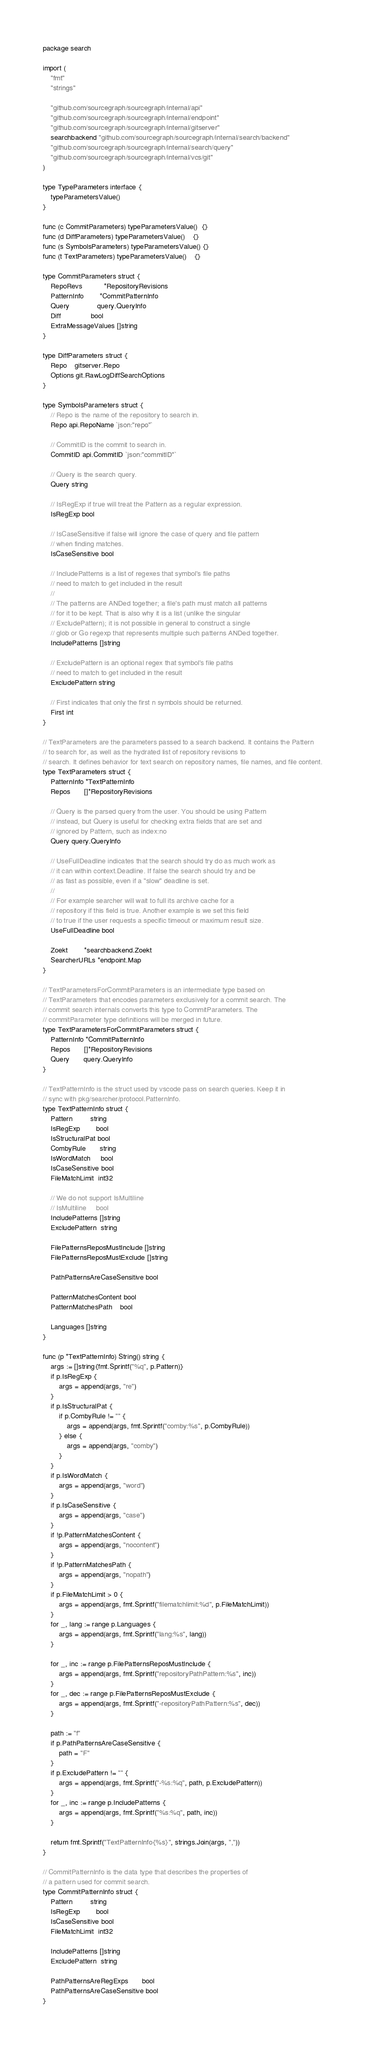Convert code to text. <code><loc_0><loc_0><loc_500><loc_500><_Go_>package search

import (
	"fmt"
	"strings"

	"github.com/sourcegraph/sourcegraph/internal/api"
	"github.com/sourcegraph/sourcegraph/internal/endpoint"
	"github.com/sourcegraph/sourcegraph/internal/gitserver"
	searchbackend "github.com/sourcegraph/sourcegraph/internal/search/backend"
	"github.com/sourcegraph/sourcegraph/internal/search/query"
	"github.com/sourcegraph/sourcegraph/internal/vcs/git"
)

type TypeParameters interface {
	typeParametersValue()
}

func (c CommitParameters) typeParametersValue()  {}
func (d DiffParameters) typeParametersValue()    {}
func (s SymbolsParameters) typeParametersValue() {}
func (t TextParameters) typeParametersValue()    {}

type CommitParameters struct {
	RepoRevs           *RepositoryRevisions
	PatternInfo        *CommitPatternInfo
	Query              query.QueryInfo
	Diff               bool
	ExtraMessageValues []string
}

type DiffParameters struct {
	Repo    gitserver.Repo
	Options git.RawLogDiffSearchOptions
}

type SymbolsParameters struct {
	// Repo is the name of the repository to search in.
	Repo api.RepoName `json:"repo"`

	// CommitID is the commit to search in.
	CommitID api.CommitID `json:"commitID"`

	// Query is the search query.
	Query string

	// IsRegExp if true will treat the Pattern as a regular expression.
	IsRegExp bool

	// IsCaseSensitive if false will ignore the case of query and file pattern
	// when finding matches.
	IsCaseSensitive bool

	// IncludePatterns is a list of regexes that symbol's file paths
	// need to match to get included in the result
	//
	// The patterns are ANDed together; a file's path must match all patterns
	// for it to be kept. That is also why it is a list (unlike the singular
	// ExcludePattern); it is not possible in general to construct a single
	// glob or Go regexp that represents multiple such patterns ANDed together.
	IncludePatterns []string

	// ExcludePattern is an optional regex that symbol's file paths
	// need to match to get included in the result
	ExcludePattern string

	// First indicates that only the first n symbols should be returned.
	First int
}

// TextParameters are the parameters passed to a search backend. It contains the Pattern
// to search for, as well as the hydrated list of repository revisions to
// search. It defines behavior for text search on repository names, file names, and file content.
type TextParameters struct {
	PatternInfo *TextPatternInfo
	Repos       []*RepositoryRevisions

	// Query is the parsed query from the user. You should be using Pattern
	// instead, but Query is useful for checking extra fields that are set and
	// ignored by Pattern, such as index:no
	Query query.QueryInfo

	// UseFullDeadline indicates that the search should try do as much work as
	// it can within context.Deadline. If false the search should try and be
	// as fast as possible, even if a "slow" deadline is set.
	//
	// For example searcher will wait to full its archive cache for a
	// repository if this field is true. Another example is we set this field
	// to true if the user requests a specific timeout or maximum result size.
	UseFullDeadline bool

	Zoekt        *searchbackend.Zoekt
	SearcherURLs *endpoint.Map
}

// TextParametersForCommitParameters is an intermediate type based on
// TextParameters that encodes parameters exclusively for a commit search. The
// commit search internals converts this type to CommitParameters. The
// commitParameter type definitions will be merged in future.
type TextParametersForCommitParameters struct {
	PatternInfo *CommitPatternInfo
	Repos       []*RepositoryRevisions
	Query       query.QueryInfo
}

// TextPatternInfo is the struct used by vscode pass on search queries. Keep it in
// sync with pkg/searcher/protocol.PatternInfo.
type TextPatternInfo struct {
	Pattern         string
	IsRegExp        bool
	IsStructuralPat bool
	CombyRule       string
	IsWordMatch     bool
	IsCaseSensitive bool
	FileMatchLimit  int32

	// We do not support IsMultiline
	// IsMultiline     bool
	IncludePatterns []string
	ExcludePattern  string

	FilePatternsReposMustInclude []string
	FilePatternsReposMustExclude []string

	PathPatternsAreCaseSensitive bool

	PatternMatchesContent bool
	PatternMatchesPath    bool

	Languages []string
}

func (p *TextPatternInfo) String() string {
	args := []string{fmt.Sprintf("%q", p.Pattern)}
	if p.IsRegExp {
		args = append(args, "re")
	}
	if p.IsStructuralPat {
		if p.CombyRule != "" {
			args = append(args, fmt.Sprintf("comby:%s", p.CombyRule))
		} else {
			args = append(args, "comby")
		}
	}
	if p.IsWordMatch {
		args = append(args, "word")
	}
	if p.IsCaseSensitive {
		args = append(args, "case")
	}
	if !p.PatternMatchesContent {
		args = append(args, "nocontent")
	}
	if !p.PatternMatchesPath {
		args = append(args, "nopath")
	}
	if p.FileMatchLimit > 0 {
		args = append(args, fmt.Sprintf("filematchlimit:%d", p.FileMatchLimit))
	}
	for _, lang := range p.Languages {
		args = append(args, fmt.Sprintf("lang:%s", lang))
	}

	for _, inc := range p.FilePatternsReposMustInclude {
		args = append(args, fmt.Sprintf("repositoryPathPattern:%s", inc))
	}
	for _, dec := range p.FilePatternsReposMustExclude {
		args = append(args, fmt.Sprintf("-repositoryPathPattern:%s", dec))
	}

	path := "f"
	if p.PathPatternsAreCaseSensitive {
		path = "F"
	}
	if p.ExcludePattern != "" {
		args = append(args, fmt.Sprintf("-%s:%q", path, p.ExcludePattern))
	}
	for _, inc := range p.IncludePatterns {
		args = append(args, fmt.Sprintf("%s:%q", path, inc))
	}

	return fmt.Sprintf("TextPatternInfo{%s}", strings.Join(args, ","))
}

// CommitPatternInfo is the data type that describes the properties of
// a pattern used for commit search.
type CommitPatternInfo struct {
	Pattern         string
	IsRegExp        bool
	IsCaseSensitive bool
	FileMatchLimit  int32

	IncludePatterns []string
	ExcludePattern  string

	PathPatternsAreRegExps       bool
	PathPatternsAreCaseSensitive bool
}
</code> 